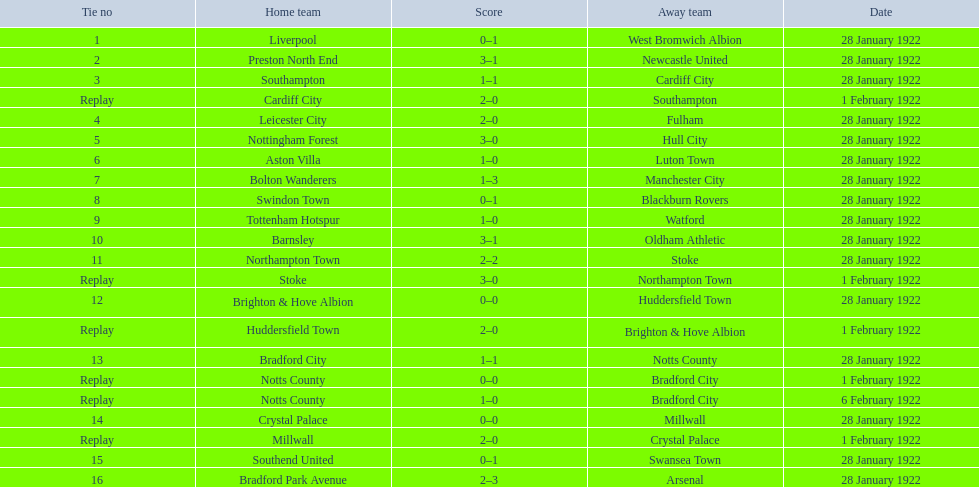In the second round proper, how many points were scored in total? 45. 